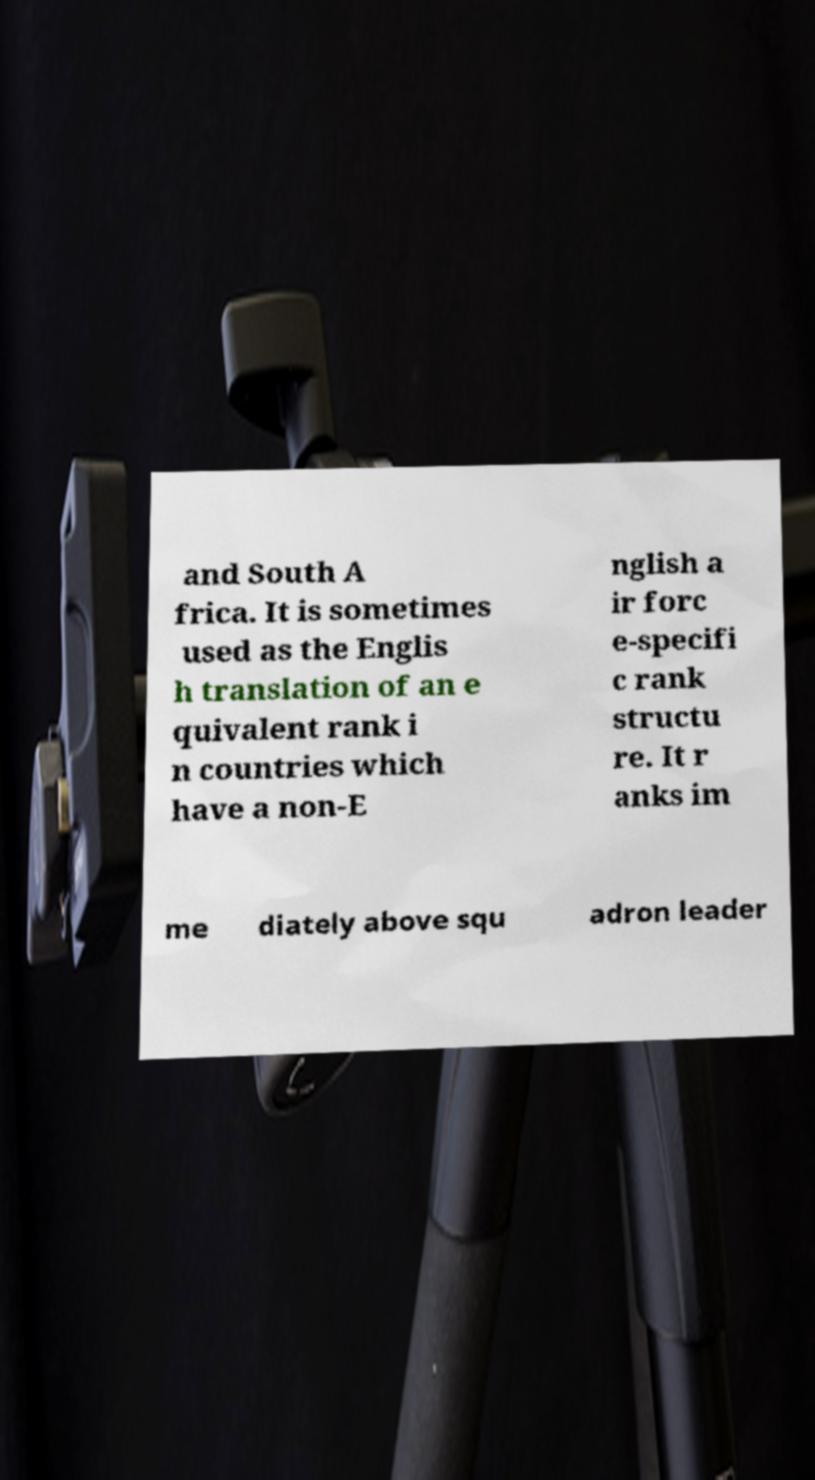Can you read and provide the text displayed in the image?This photo seems to have some interesting text. Can you extract and type it out for me? and South A frica. It is sometimes used as the Englis h translation of an e quivalent rank i n countries which have a non-E nglish a ir forc e-specifi c rank structu re. It r anks im me diately above squ adron leader 